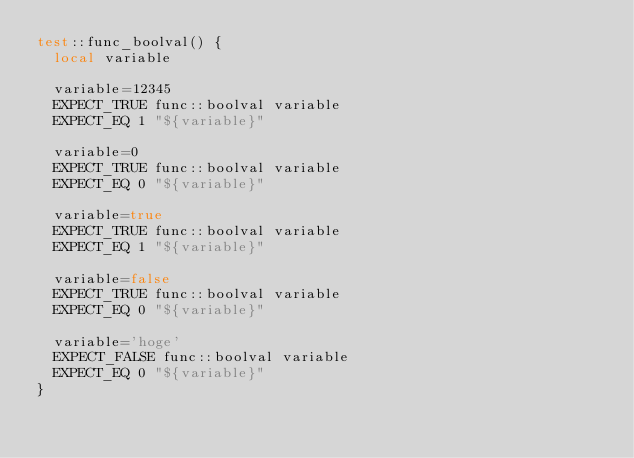<code> <loc_0><loc_0><loc_500><loc_500><_Bash_>test::func_boolval() {
  local variable

  variable=12345
  EXPECT_TRUE func::boolval variable
  EXPECT_EQ 1 "${variable}"

  variable=0
  EXPECT_TRUE func::boolval variable
  EXPECT_EQ 0 "${variable}"

  variable=true
  EXPECT_TRUE func::boolval variable
  EXPECT_EQ 1 "${variable}"

  variable=false
  EXPECT_TRUE func::boolval variable
  EXPECT_EQ 0 "${variable}"

  variable='hoge'
  EXPECT_FALSE func::boolval variable
  EXPECT_EQ 0 "${variable}"
}
</code> 